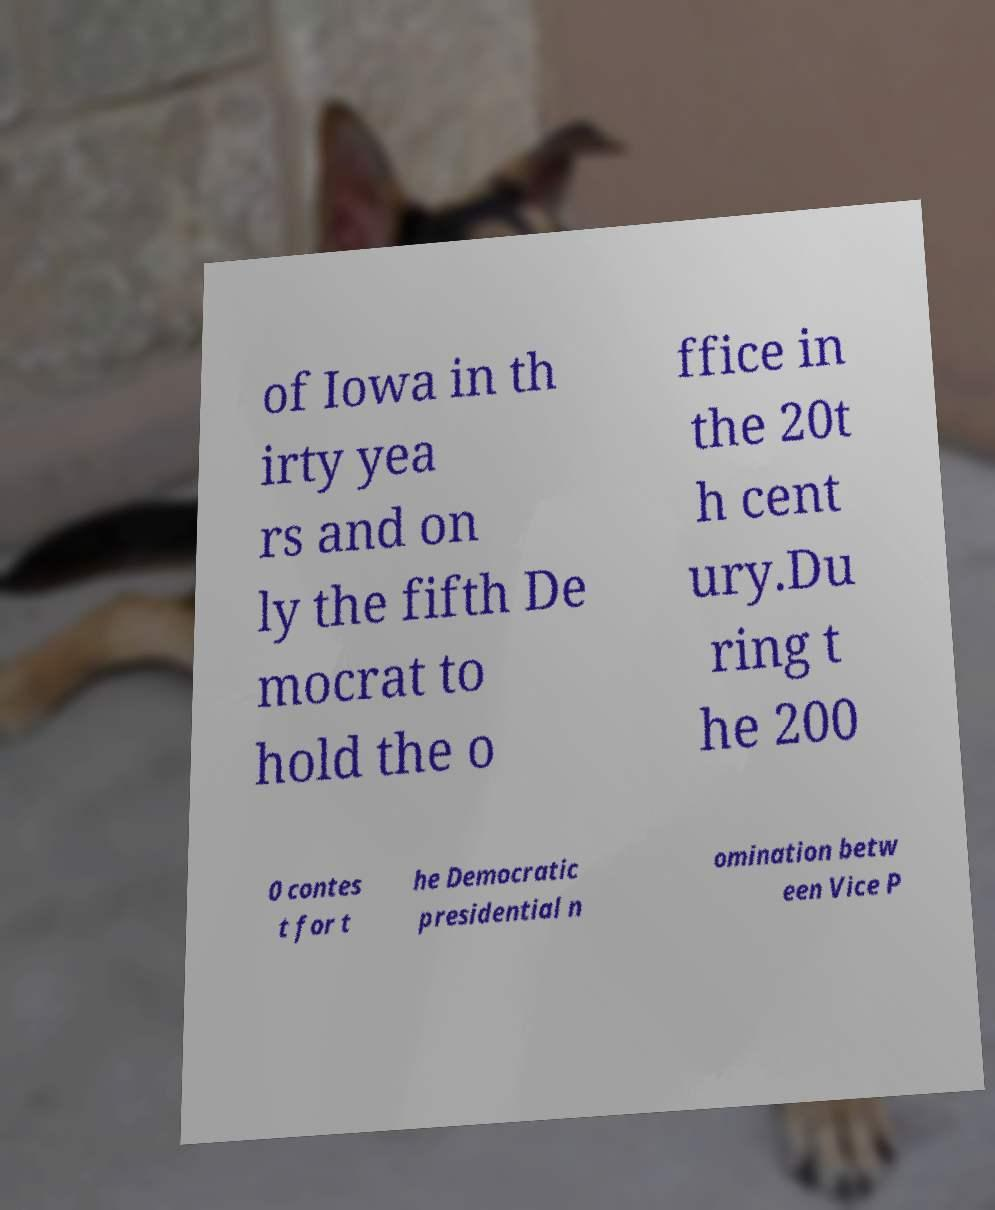Could you extract and type out the text from this image? of Iowa in th irty yea rs and on ly the fifth De mocrat to hold the o ffice in the 20t h cent ury.Du ring t he 200 0 contes t for t he Democratic presidential n omination betw een Vice P 